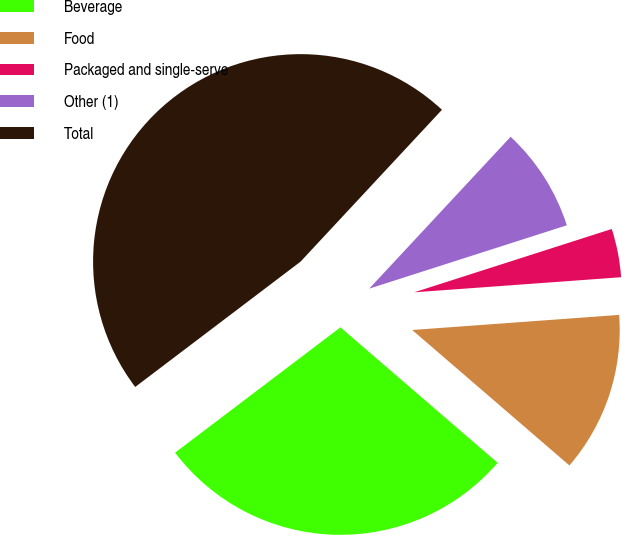Convert chart to OTSL. <chart><loc_0><loc_0><loc_500><loc_500><pie_chart><fcel>Beverage<fcel>Food<fcel>Packaged and single-serve<fcel>Other (1)<fcel>Total<nl><fcel>28.36%<fcel>12.48%<fcel>3.78%<fcel>8.13%<fcel>47.26%<nl></chart> 